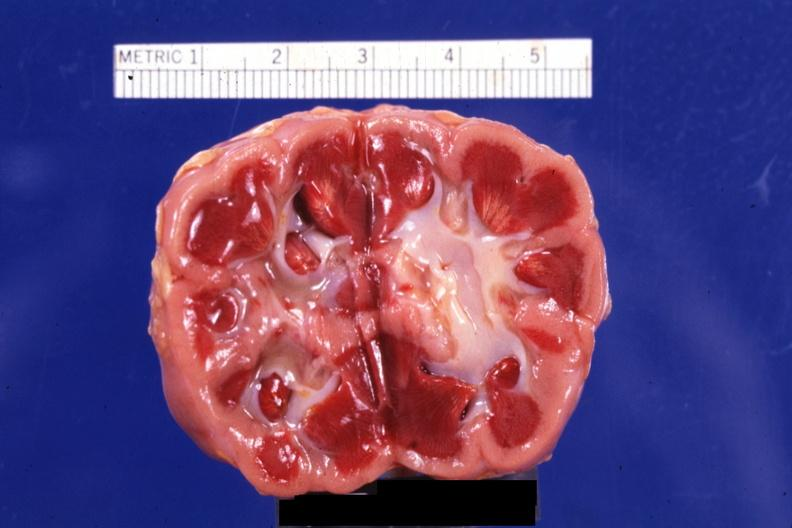what is present?
Answer the question using a single word or phrase. Ischemia 